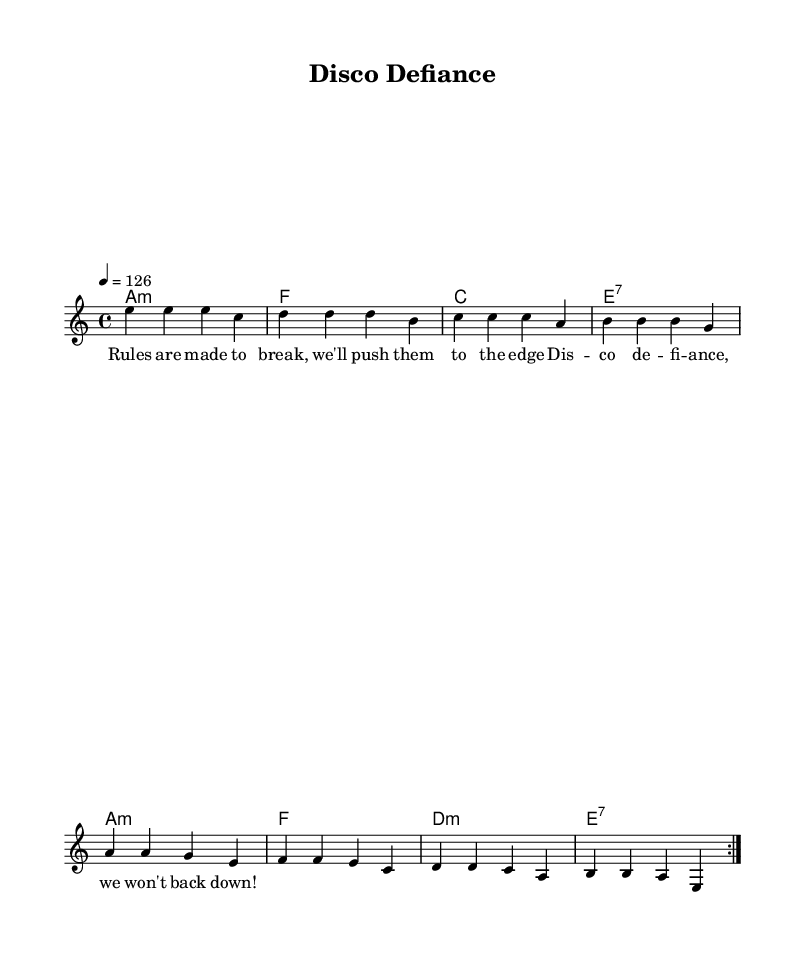What is the key signature of this music? The key signature is A minor, which has no sharps or flats.
Answer: A minor What is the time signature of the piece? The time signature shown at the beginning of the sheet music is 4/4, which indicates four beats per measure.
Answer: 4/4 What is the tempo marking indicated in the score? The tempo marking specifies the speed of the music as '4 = 126', meaning there are 126 beats per minute.
Answer: 126 How many measures are in the repeated section of the melody? The repeated section in the melody consists of 8 measures (2 repeated portions of 4 measures each).
Answer: 8 What type of chords are predominantly used in this piece? The piece predominantly features minor chords, as noted in the chord symbols provided in the harmonies.
Answer: Minor What theme does the lyrics convey? The lyrics express a theme of rebellion and defiance against authority, as mentioned in the line 'Rules are made to break.'
Answer: Rebellion What is the repeated lyric phrase in the song? The repeated lyric that captures the song's essence is 'Disco defiance', emphasizing the celebratory and subversive nature of the anthem.
Answer: Disco defiance 